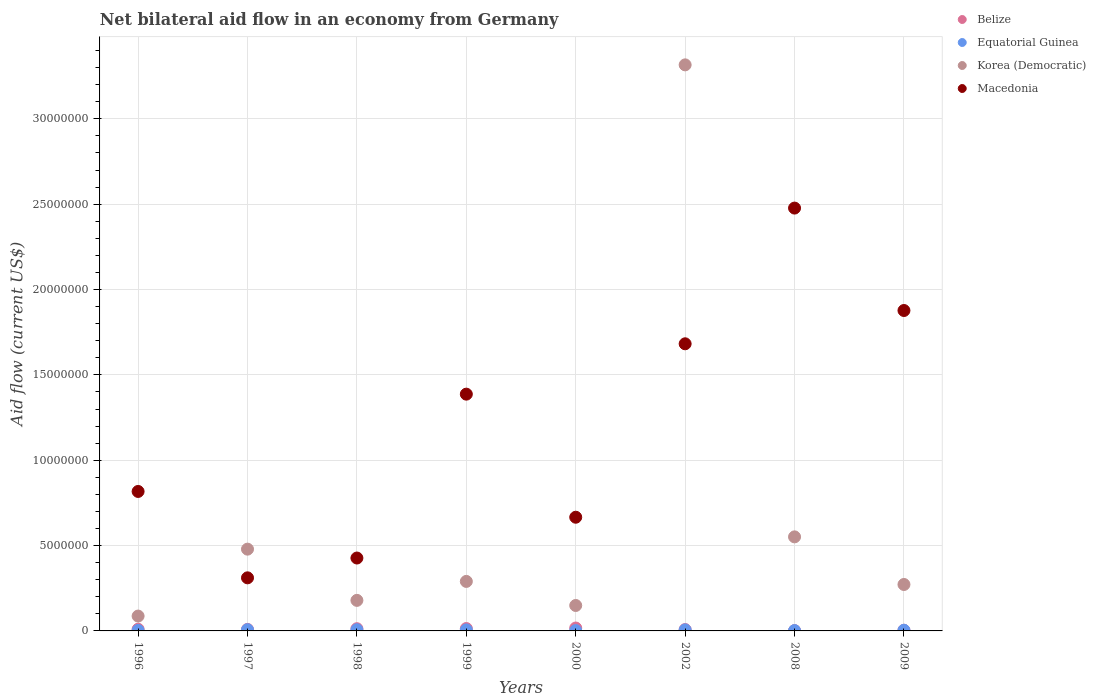Is the number of dotlines equal to the number of legend labels?
Your response must be concise. Yes. What is the net bilateral aid flow in Korea (Democratic) in 2002?
Offer a very short reply. 3.32e+07. Across all years, what is the maximum net bilateral aid flow in Belize?
Provide a short and direct response. 1.70e+05. Across all years, what is the minimum net bilateral aid flow in Korea (Democratic)?
Give a very brief answer. 8.70e+05. What is the total net bilateral aid flow in Macedonia in the graph?
Provide a short and direct response. 9.64e+07. What is the difference between the net bilateral aid flow in Belize in 1997 and the net bilateral aid flow in Equatorial Guinea in 2009?
Provide a short and direct response. 5.00e+04. What is the average net bilateral aid flow in Belize per year?
Provide a succinct answer. 9.62e+04. In how many years, is the net bilateral aid flow in Korea (Democratic) greater than 23000000 US$?
Your answer should be compact. 1. What is the ratio of the net bilateral aid flow in Macedonia in 1997 to that in 2002?
Your answer should be very brief. 0.18. What is the difference between the highest and the lowest net bilateral aid flow in Equatorial Guinea?
Make the answer very short. 5.00e+04. In how many years, is the net bilateral aid flow in Macedonia greater than the average net bilateral aid flow in Macedonia taken over all years?
Provide a short and direct response. 4. Is it the case that in every year, the sum of the net bilateral aid flow in Belize and net bilateral aid flow in Korea (Democratic)  is greater than the sum of net bilateral aid flow in Equatorial Guinea and net bilateral aid flow in Macedonia?
Your answer should be compact. Yes. Is it the case that in every year, the sum of the net bilateral aid flow in Equatorial Guinea and net bilateral aid flow in Korea (Democratic)  is greater than the net bilateral aid flow in Macedonia?
Provide a short and direct response. No. Does the net bilateral aid flow in Belize monotonically increase over the years?
Give a very brief answer. No. Is the net bilateral aid flow in Equatorial Guinea strictly greater than the net bilateral aid flow in Belize over the years?
Provide a succinct answer. No. Are the values on the major ticks of Y-axis written in scientific E-notation?
Give a very brief answer. No. Does the graph contain any zero values?
Give a very brief answer. No. Where does the legend appear in the graph?
Keep it short and to the point. Top right. What is the title of the graph?
Ensure brevity in your answer.  Net bilateral aid flow in an economy from Germany. What is the label or title of the X-axis?
Keep it short and to the point. Years. What is the Aid flow (current US$) in Belize in 1996?
Ensure brevity in your answer.  1.00e+05. What is the Aid flow (current US$) in Korea (Democratic) in 1996?
Keep it short and to the point. 8.70e+05. What is the Aid flow (current US$) in Macedonia in 1996?
Ensure brevity in your answer.  8.17e+06. What is the Aid flow (current US$) in Equatorial Guinea in 1997?
Your answer should be compact. 7.00e+04. What is the Aid flow (current US$) of Korea (Democratic) in 1997?
Ensure brevity in your answer.  4.79e+06. What is the Aid flow (current US$) of Macedonia in 1997?
Give a very brief answer. 3.11e+06. What is the Aid flow (current US$) of Belize in 1998?
Offer a very short reply. 1.30e+05. What is the Aid flow (current US$) of Equatorial Guinea in 1998?
Your response must be concise. 7.00e+04. What is the Aid flow (current US$) of Korea (Democratic) in 1998?
Provide a short and direct response. 1.79e+06. What is the Aid flow (current US$) of Macedonia in 1998?
Your answer should be compact. 4.27e+06. What is the Aid flow (current US$) of Equatorial Guinea in 1999?
Keep it short and to the point. 6.00e+04. What is the Aid flow (current US$) in Korea (Democratic) in 1999?
Your response must be concise. 2.90e+06. What is the Aid flow (current US$) of Macedonia in 1999?
Provide a succinct answer. 1.39e+07. What is the Aid flow (current US$) in Belize in 2000?
Your answer should be very brief. 1.70e+05. What is the Aid flow (current US$) of Equatorial Guinea in 2000?
Keep it short and to the point. 2.00e+04. What is the Aid flow (current US$) of Korea (Democratic) in 2000?
Provide a succinct answer. 1.49e+06. What is the Aid flow (current US$) of Macedonia in 2000?
Provide a succinct answer. 6.66e+06. What is the Aid flow (current US$) of Belize in 2002?
Keep it short and to the point. 8.00e+04. What is the Aid flow (current US$) in Korea (Democratic) in 2002?
Provide a succinct answer. 3.32e+07. What is the Aid flow (current US$) of Macedonia in 2002?
Give a very brief answer. 1.68e+07. What is the Aid flow (current US$) of Belize in 2008?
Your answer should be compact. 2.00e+04. What is the Aid flow (current US$) in Equatorial Guinea in 2008?
Keep it short and to the point. 2.00e+04. What is the Aid flow (current US$) of Korea (Democratic) in 2008?
Your answer should be compact. 5.51e+06. What is the Aid flow (current US$) of Macedonia in 2008?
Your answer should be compact. 2.48e+07. What is the Aid flow (current US$) in Belize in 2009?
Keep it short and to the point. 4.00e+04. What is the Aid flow (current US$) in Korea (Democratic) in 2009?
Provide a succinct answer. 2.72e+06. What is the Aid flow (current US$) of Macedonia in 2009?
Keep it short and to the point. 1.88e+07. Across all years, what is the maximum Aid flow (current US$) in Equatorial Guinea?
Provide a short and direct response. 7.00e+04. Across all years, what is the maximum Aid flow (current US$) of Korea (Democratic)?
Your answer should be very brief. 3.32e+07. Across all years, what is the maximum Aid flow (current US$) in Macedonia?
Provide a succinct answer. 2.48e+07. Across all years, what is the minimum Aid flow (current US$) in Belize?
Your answer should be very brief. 2.00e+04. Across all years, what is the minimum Aid flow (current US$) in Korea (Democratic)?
Offer a terse response. 8.70e+05. Across all years, what is the minimum Aid flow (current US$) in Macedonia?
Your answer should be compact. 3.11e+06. What is the total Aid flow (current US$) of Belize in the graph?
Make the answer very short. 7.70e+05. What is the total Aid flow (current US$) in Equatorial Guinea in the graph?
Keep it short and to the point. 3.70e+05. What is the total Aid flow (current US$) of Korea (Democratic) in the graph?
Your response must be concise. 5.32e+07. What is the total Aid flow (current US$) of Macedonia in the graph?
Offer a terse response. 9.64e+07. What is the difference between the Aid flow (current US$) in Korea (Democratic) in 1996 and that in 1997?
Provide a short and direct response. -3.92e+06. What is the difference between the Aid flow (current US$) in Macedonia in 1996 and that in 1997?
Offer a terse response. 5.06e+06. What is the difference between the Aid flow (current US$) of Equatorial Guinea in 1996 and that in 1998?
Keep it short and to the point. -4.00e+04. What is the difference between the Aid flow (current US$) in Korea (Democratic) in 1996 and that in 1998?
Give a very brief answer. -9.20e+05. What is the difference between the Aid flow (current US$) in Macedonia in 1996 and that in 1998?
Your answer should be compact. 3.90e+06. What is the difference between the Aid flow (current US$) in Korea (Democratic) in 1996 and that in 1999?
Give a very brief answer. -2.03e+06. What is the difference between the Aid flow (current US$) in Macedonia in 1996 and that in 1999?
Your answer should be compact. -5.70e+06. What is the difference between the Aid flow (current US$) of Belize in 1996 and that in 2000?
Keep it short and to the point. -7.00e+04. What is the difference between the Aid flow (current US$) in Equatorial Guinea in 1996 and that in 2000?
Offer a very short reply. 10000. What is the difference between the Aid flow (current US$) of Korea (Democratic) in 1996 and that in 2000?
Offer a very short reply. -6.20e+05. What is the difference between the Aid flow (current US$) of Macedonia in 1996 and that in 2000?
Provide a short and direct response. 1.51e+06. What is the difference between the Aid flow (current US$) of Korea (Democratic) in 1996 and that in 2002?
Provide a succinct answer. -3.23e+07. What is the difference between the Aid flow (current US$) in Macedonia in 1996 and that in 2002?
Your answer should be very brief. -8.65e+06. What is the difference between the Aid flow (current US$) in Belize in 1996 and that in 2008?
Your response must be concise. 8.00e+04. What is the difference between the Aid flow (current US$) of Korea (Democratic) in 1996 and that in 2008?
Offer a terse response. -4.64e+06. What is the difference between the Aid flow (current US$) in Macedonia in 1996 and that in 2008?
Provide a short and direct response. -1.66e+07. What is the difference between the Aid flow (current US$) in Belize in 1996 and that in 2009?
Your answer should be compact. 6.00e+04. What is the difference between the Aid flow (current US$) in Korea (Democratic) in 1996 and that in 2009?
Provide a succinct answer. -1.85e+06. What is the difference between the Aid flow (current US$) in Macedonia in 1996 and that in 2009?
Provide a succinct answer. -1.06e+07. What is the difference between the Aid flow (current US$) of Belize in 1997 and that in 1998?
Offer a terse response. -4.00e+04. What is the difference between the Aid flow (current US$) of Macedonia in 1997 and that in 1998?
Provide a succinct answer. -1.16e+06. What is the difference between the Aid flow (current US$) in Equatorial Guinea in 1997 and that in 1999?
Provide a succinct answer. 10000. What is the difference between the Aid flow (current US$) in Korea (Democratic) in 1997 and that in 1999?
Keep it short and to the point. 1.89e+06. What is the difference between the Aid flow (current US$) of Macedonia in 1997 and that in 1999?
Provide a short and direct response. -1.08e+07. What is the difference between the Aid flow (current US$) of Equatorial Guinea in 1997 and that in 2000?
Offer a very short reply. 5.00e+04. What is the difference between the Aid flow (current US$) of Korea (Democratic) in 1997 and that in 2000?
Offer a terse response. 3.30e+06. What is the difference between the Aid flow (current US$) of Macedonia in 1997 and that in 2000?
Make the answer very short. -3.55e+06. What is the difference between the Aid flow (current US$) of Equatorial Guinea in 1997 and that in 2002?
Your answer should be compact. 10000. What is the difference between the Aid flow (current US$) in Korea (Democratic) in 1997 and that in 2002?
Offer a terse response. -2.84e+07. What is the difference between the Aid flow (current US$) in Macedonia in 1997 and that in 2002?
Offer a terse response. -1.37e+07. What is the difference between the Aid flow (current US$) of Korea (Democratic) in 1997 and that in 2008?
Provide a succinct answer. -7.20e+05. What is the difference between the Aid flow (current US$) in Macedonia in 1997 and that in 2008?
Offer a very short reply. -2.17e+07. What is the difference between the Aid flow (current US$) of Equatorial Guinea in 1997 and that in 2009?
Offer a very short reply. 3.00e+04. What is the difference between the Aid flow (current US$) in Korea (Democratic) in 1997 and that in 2009?
Provide a succinct answer. 2.07e+06. What is the difference between the Aid flow (current US$) of Macedonia in 1997 and that in 2009?
Your answer should be compact. -1.57e+07. What is the difference between the Aid flow (current US$) of Equatorial Guinea in 1998 and that in 1999?
Ensure brevity in your answer.  10000. What is the difference between the Aid flow (current US$) of Korea (Democratic) in 1998 and that in 1999?
Your response must be concise. -1.11e+06. What is the difference between the Aid flow (current US$) in Macedonia in 1998 and that in 1999?
Your answer should be compact. -9.60e+06. What is the difference between the Aid flow (current US$) in Equatorial Guinea in 1998 and that in 2000?
Make the answer very short. 5.00e+04. What is the difference between the Aid flow (current US$) in Macedonia in 1998 and that in 2000?
Keep it short and to the point. -2.39e+06. What is the difference between the Aid flow (current US$) in Belize in 1998 and that in 2002?
Ensure brevity in your answer.  5.00e+04. What is the difference between the Aid flow (current US$) of Equatorial Guinea in 1998 and that in 2002?
Your response must be concise. 10000. What is the difference between the Aid flow (current US$) of Korea (Democratic) in 1998 and that in 2002?
Keep it short and to the point. -3.14e+07. What is the difference between the Aid flow (current US$) of Macedonia in 1998 and that in 2002?
Give a very brief answer. -1.26e+07. What is the difference between the Aid flow (current US$) in Belize in 1998 and that in 2008?
Offer a very short reply. 1.10e+05. What is the difference between the Aid flow (current US$) in Equatorial Guinea in 1998 and that in 2008?
Your response must be concise. 5.00e+04. What is the difference between the Aid flow (current US$) of Korea (Democratic) in 1998 and that in 2008?
Your answer should be very brief. -3.72e+06. What is the difference between the Aid flow (current US$) in Macedonia in 1998 and that in 2008?
Keep it short and to the point. -2.05e+07. What is the difference between the Aid flow (current US$) of Belize in 1998 and that in 2009?
Offer a very short reply. 9.00e+04. What is the difference between the Aid flow (current US$) of Equatorial Guinea in 1998 and that in 2009?
Provide a succinct answer. 3.00e+04. What is the difference between the Aid flow (current US$) of Korea (Democratic) in 1998 and that in 2009?
Provide a succinct answer. -9.30e+05. What is the difference between the Aid flow (current US$) of Macedonia in 1998 and that in 2009?
Offer a very short reply. -1.45e+07. What is the difference between the Aid flow (current US$) of Korea (Democratic) in 1999 and that in 2000?
Your answer should be compact. 1.41e+06. What is the difference between the Aid flow (current US$) in Macedonia in 1999 and that in 2000?
Offer a terse response. 7.21e+06. What is the difference between the Aid flow (current US$) of Equatorial Guinea in 1999 and that in 2002?
Offer a terse response. 0. What is the difference between the Aid flow (current US$) in Korea (Democratic) in 1999 and that in 2002?
Offer a very short reply. -3.03e+07. What is the difference between the Aid flow (current US$) of Macedonia in 1999 and that in 2002?
Provide a short and direct response. -2.95e+06. What is the difference between the Aid flow (current US$) in Equatorial Guinea in 1999 and that in 2008?
Your answer should be compact. 4.00e+04. What is the difference between the Aid flow (current US$) in Korea (Democratic) in 1999 and that in 2008?
Give a very brief answer. -2.61e+06. What is the difference between the Aid flow (current US$) in Macedonia in 1999 and that in 2008?
Offer a terse response. -1.09e+07. What is the difference between the Aid flow (current US$) in Belize in 1999 and that in 2009?
Ensure brevity in your answer.  1.00e+05. What is the difference between the Aid flow (current US$) of Equatorial Guinea in 1999 and that in 2009?
Give a very brief answer. 2.00e+04. What is the difference between the Aid flow (current US$) in Korea (Democratic) in 1999 and that in 2009?
Your answer should be compact. 1.80e+05. What is the difference between the Aid flow (current US$) in Macedonia in 1999 and that in 2009?
Give a very brief answer. -4.90e+06. What is the difference between the Aid flow (current US$) in Belize in 2000 and that in 2002?
Give a very brief answer. 9.00e+04. What is the difference between the Aid flow (current US$) in Korea (Democratic) in 2000 and that in 2002?
Keep it short and to the point. -3.17e+07. What is the difference between the Aid flow (current US$) in Macedonia in 2000 and that in 2002?
Provide a succinct answer. -1.02e+07. What is the difference between the Aid flow (current US$) in Belize in 2000 and that in 2008?
Ensure brevity in your answer.  1.50e+05. What is the difference between the Aid flow (current US$) in Equatorial Guinea in 2000 and that in 2008?
Offer a very short reply. 0. What is the difference between the Aid flow (current US$) in Korea (Democratic) in 2000 and that in 2008?
Your response must be concise. -4.02e+06. What is the difference between the Aid flow (current US$) in Macedonia in 2000 and that in 2008?
Your response must be concise. -1.81e+07. What is the difference between the Aid flow (current US$) of Korea (Democratic) in 2000 and that in 2009?
Your answer should be very brief. -1.23e+06. What is the difference between the Aid flow (current US$) in Macedonia in 2000 and that in 2009?
Your response must be concise. -1.21e+07. What is the difference between the Aid flow (current US$) in Belize in 2002 and that in 2008?
Provide a succinct answer. 6.00e+04. What is the difference between the Aid flow (current US$) of Korea (Democratic) in 2002 and that in 2008?
Your answer should be compact. 2.76e+07. What is the difference between the Aid flow (current US$) in Macedonia in 2002 and that in 2008?
Ensure brevity in your answer.  -7.95e+06. What is the difference between the Aid flow (current US$) in Korea (Democratic) in 2002 and that in 2009?
Offer a very short reply. 3.04e+07. What is the difference between the Aid flow (current US$) in Macedonia in 2002 and that in 2009?
Keep it short and to the point. -1.95e+06. What is the difference between the Aid flow (current US$) in Belize in 2008 and that in 2009?
Your answer should be compact. -2.00e+04. What is the difference between the Aid flow (current US$) in Equatorial Guinea in 2008 and that in 2009?
Your response must be concise. -2.00e+04. What is the difference between the Aid flow (current US$) of Korea (Democratic) in 2008 and that in 2009?
Your answer should be compact. 2.79e+06. What is the difference between the Aid flow (current US$) in Macedonia in 2008 and that in 2009?
Provide a short and direct response. 6.00e+06. What is the difference between the Aid flow (current US$) of Belize in 1996 and the Aid flow (current US$) of Equatorial Guinea in 1997?
Give a very brief answer. 3.00e+04. What is the difference between the Aid flow (current US$) of Belize in 1996 and the Aid flow (current US$) of Korea (Democratic) in 1997?
Offer a terse response. -4.69e+06. What is the difference between the Aid flow (current US$) in Belize in 1996 and the Aid flow (current US$) in Macedonia in 1997?
Your answer should be very brief. -3.01e+06. What is the difference between the Aid flow (current US$) in Equatorial Guinea in 1996 and the Aid flow (current US$) in Korea (Democratic) in 1997?
Provide a short and direct response. -4.76e+06. What is the difference between the Aid flow (current US$) of Equatorial Guinea in 1996 and the Aid flow (current US$) of Macedonia in 1997?
Offer a very short reply. -3.08e+06. What is the difference between the Aid flow (current US$) in Korea (Democratic) in 1996 and the Aid flow (current US$) in Macedonia in 1997?
Offer a terse response. -2.24e+06. What is the difference between the Aid flow (current US$) in Belize in 1996 and the Aid flow (current US$) in Korea (Democratic) in 1998?
Offer a very short reply. -1.69e+06. What is the difference between the Aid flow (current US$) of Belize in 1996 and the Aid flow (current US$) of Macedonia in 1998?
Provide a short and direct response. -4.17e+06. What is the difference between the Aid flow (current US$) of Equatorial Guinea in 1996 and the Aid flow (current US$) of Korea (Democratic) in 1998?
Your answer should be compact. -1.76e+06. What is the difference between the Aid flow (current US$) in Equatorial Guinea in 1996 and the Aid flow (current US$) in Macedonia in 1998?
Provide a short and direct response. -4.24e+06. What is the difference between the Aid flow (current US$) of Korea (Democratic) in 1996 and the Aid flow (current US$) of Macedonia in 1998?
Provide a short and direct response. -3.40e+06. What is the difference between the Aid flow (current US$) in Belize in 1996 and the Aid flow (current US$) in Korea (Democratic) in 1999?
Provide a short and direct response. -2.80e+06. What is the difference between the Aid flow (current US$) of Belize in 1996 and the Aid flow (current US$) of Macedonia in 1999?
Your answer should be compact. -1.38e+07. What is the difference between the Aid flow (current US$) in Equatorial Guinea in 1996 and the Aid flow (current US$) in Korea (Democratic) in 1999?
Make the answer very short. -2.87e+06. What is the difference between the Aid flow (current US$) of Equatorial Guinea in 1996 and the Aid flow (current US$) of Macedonia in 1999?
Your response must be concise. -1.38e+07. What is the difference between the Aid flow (current US$) of Korea (Democratic) in 1996 and the Aid flow (current US$) of Macedonia in 1999?
Your answer should be compact. -1.30e+07. What is the difference between the Aid flow (current US$) of Belize in 1996 and the Aid flow (current US$) of Korea (Democratic) in 2000?
Provide a succinct answer. -1.39e+06. What is the difference between the Aid flow (current US$) in Belize in 1996 and the Aid flow (current US$) in Macedonia in 2000?
Provide a succinct answer. -6.56e+06. What is the difference between the Aid flow (current US$) of Equatorial Guinea in 1996 and the Aid flow (current US$) of Korea (Democratic) in 2000?
Your response must be concise. -1.46e+06. What is the difference between the Aid flow (current US$) of Equatorial Guinea in 1996 and the Aid flow (current US$) of Macedonia in 2000?
Your answer should be very brief. -6.63e+06. What is the difference between the Aid flow (current US$) in Korea (Democratic) in 1996 and the Aid flow (current US$) in Macedonia in 2000?
Your answer should be compact. -5.79e+06. What is the difference between the Aid flow (current US$) of Belize in 1996 and the Aid flow (current US$) of Korea (Democratic) in 2002?
Keep it short and to the point. -3.31e+07. What is the difference between the Aid flow (current US$) of Belize in 1996 and the Aid flow (current US$) of Macedonia in 2002?
Give a very brief answer. -1.67e+07. What is the difference between the Aid flow (current US$) in Equatorial Guinea in 1996 and the Aid flow (current US$) in Korea (Democratic) in 2002?
Give a very brief answer. -3.31e+07. What is the difference between the Aid flow (current US$) of Equatorial Guinea in 1996 and the Aid flow (current US$) of Macedonia in 2002?
Ensure brevity in your answer.  -1.68e+07. What is the difference between the Aid flow (current US$) of Korea (Democratic) in 1996 and the Aid flow (current US$) of Macedonia in 2002?
Give a very brief answer. -1.60e+07. What is the difference between the Aid flow (current US$) in Belize in 1996 and the Aid flow (current US$) in Equatorial Guinea in 2008?
Your answer should be very brief. 8.00e+04. What is the difference between the Aid flow (current US$) of Belize in 1996 and the Aid flow (current US$) of Korea (Democratic) in 2008?
Give a very brief answer. -5.41e+06. What is the difference between the Aid flow (current US$) in Belize in 1996 and the Aid flow (current US$) in Macedonia in 2008?
Give a very brief answer. -2.47e+07. What is the difference between the Aid flow (current US$) in Equatorial Guinea in 1996 and the Aid flow (current US$) in Korea (Democratic) in 2008?
Give a very brief answer. -5.48e+06. What is the difference between the Aid flow (current US$) of Equatorial Guinea in 1996 and the Aid flow (current US$) of Macedonia in 2008?
Your response must be concise. -2.47e+07. What is the difference between the Aid flow (current US$) of Korea (Democratic) in 1996 and the Aid flow (current US$) of Macedonia in 2008?
Make the answer very short. -2.39e+07. What is the difference between the Aid flow (current US$) in Belize in 1996 and the Aid flow (current US$) in Equatorial Guinea in 2009?
Your answer should be very brief. 6.00e+04. What is the difference between the Aid flow (current US$) of Belize in 1996 and the Aid flow (current US$) of Korea (Democratic) in 2009?
Your answer should be compact. -2.62e+06. What is the difference between the Aid flow (current US$) of Belize in 1996 and the Aid flow (current US$) of Macedonia in 2009?
Provide a short and direct response. -1.87e+07. What is the difference between the Aid flow (current US$) in Equatorial Guinea in 1996 and the Aid flow (current US$) in Korea (Democratic) in 2009?
Give a very brief answer. -2.69e+06. What is the difference between the Aid flow (current US$) of Equatorial Guinea in 1996 and the Aid flow (current US$) of Macedonia in 2009?
Keep it short and to the point. -1.87e+07. What is the difference between the Aid flow (current US$) of Korea (Democratic) in 1996 and the Aid flow (current US$) of Macedonia in 2009?
Provide a succinct answer. -1.79e+07. What is the difference between the Aid flow (current US$) of Belize in 1997 and the Aid flow (current US$) of Korea (Democratic) in 1998?
Your answer should be very brief. -1.70e+06. What is the difference between the Aid flow (current US$) of Belize in 1997 and the Aid flow (current US$) of Macedonia in 1998?
Give a very brief answer. -4.18e+06. What is the difference between the Aid flow (current US$) in Equatorial Guinea in 1997 and the Aid flow (current US$) in Korea (Democratic) in 1998?
Ensure brevity in your answer.  -1.72e+06. What is the difference between the Aid flow (current US$) of Equatorial Guinea in 1997 and the Aid flow (current US$) of Macedonia in 1998?
Provide a short and direct response. -4.20e+06. What is the difference between the Aid flow (current US$) of Korea (Democratic) in 1997 and the Aid flow (current US$) of Macedonia in 1998?
Provide a succinct answer. 5.20e+05. What is the difference between the Aid flow (current US$) of Belize in 1997 and the Aid flow (current US$) of Equatorial Guinea in 1999?
Give a very brief answer. 3.00e+04. What is the difference between the Aid flow (current US$) of Belize in 1997 and the Aid flow (current US$) of Korea (Democratic) in 1999?
Provide a succinct answer. -2.81e+06. What is the difference between the Aid flow (current US$) in Belize in 1997 and the Aid flow (current US$) in Macedonia in 1999?
Make the answer very short. -1.38e+07. What is the difference between the Aid flow (current US$) in Equatorial Guinea in 1997 and the Aid flow (current US$) in Korea (Democratic) in 1999?
Provide a succinct answer. -2.83e+06. What is the difference between the Aid flow (current US$) in Equatorial Guinea in 1997 and the Aid flow (current US$) in Macedonia in 1999?
Your response must be concise. -1.38e+07. What is the difference between the Aid flow (current US$) of Korea (Democratic) in 1997 and the Aid flow (current US$) of Macedonia in 1999?
Offer a very short reply. -9.08e+06. What is the difference between the Aid flow (current US$) in Belize in 1997 and the Aid flow (current US$) in Korea (Democratic) in 2000?
Offer a very short reply. -1.40e+06. What is the difference between the Aid flow (current US$) of Belize in 1997 and the Aid flow (current US$) of Macedonia in 2000?
Offer a very short reply. -6.57e+06. What is the difference between the Aid flow (current US$) in Equatorial Guinea in 1997 and the Aid flow (current US$) in Korea (Democratic) in 2000?
Make the answer very short. -1.42e+06. What is the difference between the Aid flow (current US$) in Equatorial Guinea in 1997 and the Aid flow (current US$) in Macedonia in 2000?
Provide a succinct answer. -6.59e+06. What is the difference between the Aid flow (current US$) of Korea (Democratic) in 1997 and the Aid flow (current US$) of Macedonia in 2000?
Ensure brevity in your answer.  -1.87e+06. What is the difference between the Aid flow (current US$) in Belize in 1997 and the Aid flow (current US$) in Korea (Democratic) in 2002?
Offer a very short reply. -3.31e+07. What is the difference between the Aid flow (current US$) of Belize in 1997 and the Aid flow (current US$) of Macedonia in 2002?
Ensure brevity in your answer.  -1.67e+07. What is the difference between the Aid flow (current US$) of Equatorial Guinea in 1997 and the Aid flow (current US$) of Korea (Democratic) in 2002?
Provide a succinct answer. -3.31e+07. What is the difference between the Aid flow (current US$) of Equatorial Guinea in 1997 and the Aid flow (current US$) of Macedonia in 2002?
Provide a short and direct response. -1.68e+07. What is the difference between the Aid flow (current US$) in Korea (Democratic) in 1997 and the Aid flow (current US$) in Macedonia in 2002?
Provide a succinct answer. -1.20e+07. What is the difference between the Aid flow (current US$) in Belize in 1997 and the Aid flow (current US$) in Korea (Democratic) in 2008?
Your answer should be very brief. -5.42e+06. What is the difference between the Aid flow (current US$) of Belize in 1997 and the Aid flow (current US$) of Macedonia in 2008?
Provide a short and direct response. -2.47e+07. What is the difference between the Aid flow (current US$) of Equatorial Guinea in 1997 and the Aid flow (current US$) of Korea (Democratic) in 2008?
Ensure brevity in your answer.  -5.44e+06. What is the difference between the Aid flow (current US$) of Equatorial Guinea in 1997 and the Aid flow (current US$) of Macedonia in 2008?
Make the answer very short. -2.47e+07. What is the difference between the Aid flow (current US$) in Korea (Democratic) in 1997 and the Aid flow (current US$) in Macedonia in 2008?
Your answer should be very brief. -2.00e+07. What is the difference between the Aid flow (current US$) in Belize in 1997 and the Aid flow (current US$) in Equatorial Guinea in 2009?
Your response must be concise. 5.00e+04. What is the difference between the Aid flow (current US$) in Belize in 1997 and the Aid flow (current US$) in Korea (Democratic) in 2009?
Ensure brevity in your answer.  -2.63e+06. What is the difference between the Aid flow (current US$) of Belize in 1997 and the Aid flow (current US$) of Macedonia in 2009?
Ensure brevity in your answer.  -1.87e+07. What is the difference between the Aid flow (current US$) in Equatorial Guinea in 1997 and the Aid flow (current US$) in Korea (Democratic) in 2009?
Your answer should be very brief. -2.65e+06. What is the difference between the Aid flow (current US$) of Equatorial Guinea in 1997 and the Aid flow (current US$) of Macedonia in 2009?
Your response must be concise. -1.87e+07. What is the difference between the Aid flow (current US$) in Korea (Democratic) in 1997 and the Aid flow (current US$) in Macedonia in 2009?
Provide a short and direct response. -1.40e+07. What is the difference between the Aid flow (current US$) in Belize in 1998 and the Aid flow (current US$) in Equatorial Guinea in 1999?
Keep it short and to the point. 7.00e+04. What is the difference between the Aid flow (current US$) of Belize in 1998 and the Aid flow (current US$) of Korea (Democratic) in 1999?
Your response must be concise. -2.77e+06. What is the difference between the Aid flow (current US$) in Belize in 1998 and the Aid flow (current US$) in Macedonia in 1999?
Your answer should be very brief. -1.37e+07. What is the difference between the Aid flow (current US$) of Equatorial Guinea in 1998 and the Aid flow (current US$) of Korea (Democratic) in 1999?
Offer a terse response. -2.83e+06. What is the difference between the Aid flow (current US$) in Equatorial Guinea in 1998 and the Aid flow (current US$) in Macedonia in 1999?
Your response must be concise. -1.38e+07. What is the difference between the Aid flow (current US$) in Korea (Democratic) in 1998 and the Aid flow (current US$) in Macedonia in 1999?
Offer a very short reply. -1.21e+07. What is the difference between the Aid flow (current US$) of Belize in 1998 and the Aid flow (current US$) of Korea (Democratic) in 2000?
Give a very brief answer. -1.36e+06. What is the difference between the Aid flow (current US$) of Belize in 1998 and the Aid flow (current US$) of Macedonia in 2000?
Your response must be concise. -6.53e+06. What is the difference between the Aid flow (current US$) in Equatorial Guinea in 1998 and the Aid flow (current US$) in Korea (Democratic) in 2000?
Make the answer very short. -1.42e+06. What is the difference between the Aid flow (current US$) in Equatorial Guinea in 1998 and the Aid flow (current US$) in Macedonia in 2000?
Provide a succinct answer. -6.59e+06. What is the difference between the Aid flow (current US$) of Korea (Democratic) in 1998 and the Aid flow (current US$) of Macedonia in 2000?
Your response must be concise. -4.87e+06. What is the difference between the Aid flow (current US$) of Belize in 1998 and the Aid flow (current US$) of Equatorial Guinea in 2002?
Your response must be concise. 7.00e+04. What is the difference between the Aid flow (current US$) in Belize in 1998 and the Aid flow (current US$) in Korea (Democratic) in 2002?
Your answer should be compact. -3.30e+07. What is the difference between the Aid flow (current US$) of Belize in 1998 and the Aid flow (current US$) of Macedonia in 2002?
Provide a succinct answer. -1.67e+07. What is the difference between the Aid flow (current US$) of Equatorial Guinea in 1998 and the Aid flow (current US$) of Korea (Democratic) in 2002?
Ensure brevity in your answer.  -3.31e+07. What is the difference between the Aid flow (current US$) in Equatorial Guinea in 1998 and the Aid flow (current US$) in Macedonia in 2002?
Offer a very short reply. -1.68e+07. What is the difference between the Aid flow (current US$) of Korea (Democratic) in 1998 and the Aid flow (current US$) of Macedonia in 2002?
Offer a terse response. -1.50e+07. What is the difference between the Aid flow (current US$) in Belize in 1998 and the Aid flow (current US$) in Equatorial Guinea in 2008?
Offer a very short reply. 1.10e+05. What is the difference between the Aid flow (current US$) of Belize in 1998 and the Aid flow (current US$) of Korea (Democratic) in 2008?
Give a very brief answer. -5.38e+06. What is the difference between the Aid flow (current US$) of Belize in 1998 and the Aid flow (current US$) of Macedonia in 2008?
Provide a short and direct response. -2.46e+07. What is the difference between the Aid flow (current US$) of Equatorial Guinea in 1998 and the Aid flow (current US$) of Korea (Democratic) in 2008?
Give a very brief answer. -5.44e+06. What is the difference between the Aid flow (current US$) in Equatorial Guinea in 1998 and the Aid flow (current US$) in Macedonia in 2008?
Keep it short and to the point. -2.47e+07. What is the difference between the Aid flow (current US$) of Korea (Democratic) in 1998 and the Aid flow (current US$) of Macedonia in 2008?
Offer a terse response. -2.30e+07. What is the difference between the Aid flow (current US$) in Belize in 1998 and the Aid flow (current US$) in Korea (Democratic) in 2009?
Provide a succinct answer. -2.59e+06. What is the difference between the Aid flow (current US$) of Belize in 1998 and the Aid flow (current US$) of Macedonia in 2009?
Keep it short and to the point. -1.86e+07. What is the difference between the Aid flow (current US$) of Equatorial Guinea in 1998 and the Aid flow (current US$) of Korea (Democratic) in 2009?
Give a very brief answer. -2.65e+06. What is the difference between the Aid flow (current US$) of Equatorial Guinea in 1998 and the Aid flow (current US$) of Macedonia in 2009?
Provide a succinct answer. -1.87e+07. What is the difference between the Aid flow (current US$) in Korea (Democratic) in 1998 and the Aid flow (current US$) in Macedonia in 2009?
Make the answer very short. -1.70e+07. What is the difference between the Aid flow (current US$) of Belize in 1999 and the Aid flow (current US$) of Equatorial Guinea in 2000?
Offer a very short reply. 1.20e+05. What is the difference between the Aid flow (current US$) in Belize in 1999 and the Aid flow (current US$) in Korea (Democratic) in 2000?
Offer a terse response. -1.35e+06. What is the difference between the Aid flow (current US$) in Belize in 1999 and the Aid flow (current US$) in Macedonia in 2000?
Your answer should be compact. -6.52e+06. What is the difference between the Aid flow (current US$) of Equatorial Guinea in 1999 and the Aid flow (current US$) of Korea (Democratic) in 2000?
Provide a short and direct response. -1.43e+06. What is the difference between the Aid flow (current US$) in Equatorial Guinea in 1999 and the Aid flow (current US$) in Macedonia in 2000?
Your answer should be compact. -6.60e+06. What is the difference between the Aid flow (current US$) in Korea (Democratic) in 1999 and the Aid flow (current US$) in Macedonia in 2000?
Your answer should be compact. -3.76e+06. What is the difference between the Aid flow (current US$) in Belize in 1999 and the Aid flow (current US$) in Equatorial Guinea in 2002?
Ensure brevity in your answer.  8.00e+04. What is the difference between the Aid flow (current US$) of Belize in 1999 and the Aid flow (current US$) of Korea (Democratic) in 2002?
Keep it short and to the point. -3.30e+07. What is the difference between the Aid flow (current US$) in Belize in 1999 and the Aid flow (current US$) in Macedonia in 2002?
Provide a short and direct response. -1.67e+07. What is the difference between the Aid flow (current US$) of Equatorial Guinea in 1999 and the Aid flow (current US$) of Korea (Democratic) in 2002?
Make the answer very short. -3.31e+07. What is the difference between the Aid flow (current US$) of Equatorial Guinea in 1999 and the Aid flow (current US$) of Macedonia in 2002?
Ensure brevity in your answer.  -1.68e+07. What is the difference between the Aid flow (current US$) of Korea (Democratic) in 1999 and the Aid flow (current US$) of Macedonia in 2002?
Give a very brief answer. -1.39e+07. What is the difference between the Aid flow (current US$) in Belize in 1999 and the Aid flow (current US$) in Equatorial Guinea in 2008?
Make the answer very short. 1.20e+05. What is the difference between the Aid flow (current US$) in Belize in 1999 and the Aid flow (current US$) in Korea (Democratic) in 2008?
Ensure brevity in your answer.  -5.37e+06. What is the difference between the Aid flow (current US$) in Belize in 1999 and the Aid flow (current US$) in Macedonia in 2008?
Your answer should be very brief. -2.46e+07. What is the difference between the Aid flow (current US$) in Equatorial Guinea in 1999 and the Aid flow (current US$) in Korea (Democratic) in 2008?
Make the answer very short. -5.45e+06. What is the difference between the Aid flow (current US$) in Equatorial Guinea in 1999 and the Aid flow (current US$) in Macedonia in 2008?
Provide a succinct answer. -2.47e+07. What is the difference between the Aid flow (current US$) of Korea (Democratic) in 1999 and the Aid flow (current US$) of Macedonia in 2008?
Make the answer very short. -2.19e+07. What is the difference between the Aid flow (current US$) in Belize in 1999 and the Aid flow (current US$) in Korea (Democratic) in 2009?
Provide a succinct answer. -2.58e+06. What is the difference between the Aid flow (current US$) of Belize in 1999 and the Aid flow (current US$) of Macedonia in 2009?
Keep it short and to the point. -1.86e+07. What is the difference between the Aid flow (current US$) of Equatorial Guinea in 1999 and the Aid flow (current US$) of Korea (Democratic) in 2009?
Give a very brief answer. -2.66e+06. What is the difference between the Aid flow (current US$) in Equatorial Guinea in 1999 and the Aid flow (current US$) in Macedonia in 2009?
Offer a very short reply. -1.87e+07. What is the difference between the Aid flow (current US$) of Korea (Democratic) in 1999 and the Aid flow (current US$) of Macedonia in 2009?
Offer a terse response. -1.59e+07. What is the difference between the Aid flow (current US$) in Belize in 2000 and the Aid flow (current US$) in Equatorial Guinea in 2002?
Offer a very short reply. 1.10e+05. What is the difference between the Aid flow (current US$) of Belize in 2000 and the Aid flow (current US$) of Korea (Democratic) in 2002?
Keep it short and to the point. -3.30e+07. What is the difference between the Aid flow (current US$) in Belize in 2000 and the Aid flow (current US$) in Macedonia in 2002?
Offer a terse response. -1.66e+07. What is the difference between the Aid flow (current US$) in Equatorial Guinea in 2000 and the Aid flow (current US$) in Korea (Democratic) in 2002?
Provide a succinct answer. -3.31e+07. What is the difference between the Aid flow (current US$) in Equatorial Guinea in 2000 and the Aid flow (current US$) in Macedonia in 2002?
Ensure brevity in your answer.  -1.68e+07. What is the difference between the Aid flow (current US$) of Korea (Democratic) in 2000 and the Aid flow (current US$) of Macedonia in 2002?
Offer a terse response. -1.53e+07. What is the difference between the Aid flow (current US$) of Belize in 2000 and the Aid flow (current US$) of Korea (Democratic) in 2008?
Offer a terse response. -5.34e+06. What is the difference between the Aid flow (current US$) of Belize in 2000 and the Aid flow (current US$) of Macedonia in 2008?
Keep it short and to the point. -2.46e+07. What is the difference between the Aid flow (current US$) of Equatorial Guinea in 2000 and the Aid flow (current US$) of Korea (Democratic) in 2008?
Offer a terse response. -5.49e+06. What is the difference between the Aid flow (current US$) in Equatorial Guinea in 2000 and the Aid flow (current US$) in Macedonia in 2008?
Offer a terse response. -2.48e+07. What is the difference between the Aid flow (current US$) in Korea (Democratic) in 2000 and the Aid flow (current US$) in Macedonia in 2008?
Ensure brevity in your answer.  -2.33e+07. What is the difference between the Aid flow (current US$) in Belize in 2000 and the Aid flow (current US$) in Equatorial Guinea in 2009?
Offer a terse response. 1.30e+05. What is the difference between the Aid flow (current US$) in Belize in 2000 and the Aid flow (current US$) in Korea (Democratic) in 2009?
Provide a succinct answer. -2.55e+06. What is the difference between the Aid flow (current US$) of Belize in 2000 and the Aid flow (current US$) of Macedonia in 2009?
Offer a terse response. -1.86e+07. What is the difference between the Aid flow (current US$) in Equatorial Guinea in 2000 and the Aid flow (current US$) in Korea (Democratic) in 2009?
Give a very brief answer. -2.70e+06. What is the difference between the Aid flow (current US$) of Equatorial Guinea in 2000 and the Aid flow (current US$) of Macedonia in 2009?
Keep it short and to the point. -1.88e+07. What is the difference between the Aid flow (current US$) in Korea (Democratic) in 2000 and the Aid flow (current US$) in Macedonia in 2009?
Make the answer very short. -1.73e+07. What is the difference between the Aid flow (current US$) of Belize in 2002 and the Aid flow (current US$) of Equatorial Guinea in 2008?
Ensure brevity in your answer.  6.00e+04. What is the difference between the Aid flow (current US$) in Belize in 2002 and the Aid flow (current US$) in Korea (Democratic) in 2008?
Make the answer very short. -5.43e+06. What is the difference between the Aid flow (current US$) of Belize in 2002 and the Aid flow (current US$) of Macedonia in 2008?
Make the answer very short. -2.47e+07. What is the difference between the Aid flow (current US$) of Equatorial Guinea in 2002 and the Aid flow (current US$) of Korea (Democratic) in 2008?
Ensure brevity in your answer.  -5.45e+06. What is the difference between the Aid flow (current US$) in Equatorial Guinea in 2002 and the Aid flow (current US$) in Macedonia in 2008?
Your answer should be compact. -2.47e+07. What is the difference between the Aid flow (current US$) in Korea (Democratic) in 2002 and the Aid flow (current US$) in Macedonia in 2008?
Provide a short and direct response. 8.39e+06. What is the difference between the Aid flow (current US$) of Belize in 2002 and the Aid flow (current US$) of Korea (Democratic) in 2009?
Offer a terse response. -2.64e+06. What is the difference between the Aid flow (current US$) of Belize in 2002 and the Aid flow (current US$) of Macedonia in 2009?
Keep it short and to the point. -1.87e+07. What is the difference between the Aid flow (current US$) of Equatorial Guinea in 2002 and the Aid flow (current US$) of Korea (Democratic) in 2009?
Offer a very short reply. -2.66e+06. What is the difference between the Aid flow (current US$) in Equatorial Guinea in 2002 and the Aid flow (current US$) in Macedonia in 2009?
Your answer should be compact. -1.87e+07. What is the difference between the Aid flow (current US$) in Korea (Democratic) in 2002 and the Aid flow (current US$) in Macedonia in 2009?
Provide a succinct answer. 1.44e+07. What is the difference between the Aid flow (current US$) of Belize in 2008 and the Aid flow (current US$) of Equatorial Guinea in 2009?
Provide a short and direct response. -2.00e+04. What is the difference between the Aid flow (current US$) of Belize in 2008 and the Aid flow (current US$) of Korea (Democratic) in 2009?
Your answer should be compact. -2.70e+06. What is the difference between the Aid flow (current US$) in Belize in 2008 and the Aid flow (current US$) in Macedonia in 2009?
Keep it short and to the point. -1.88e+07. What is the difference between the Aid flow (current US$) in Equatorial Guinea in 2008 and the Aid flow (current US$) in Korea (Democratic) in 2009?
Give a very brief answer. -2.70e+06. What is the difference between the Aid flow (current US$) of Equatorial Guinea in 2008 and the Aid flow (current US$) of Macedonia in 2009?
Your answer should be very brief. -1.88e+07. What is the difference between the Aid flow (current US$) in Korea (Democratic) in 2008 and the Aid flow (current US$) in Macedonia in 2009?
Your answer should be compact. -1.33e+07. What is the average Aid flow (current US$) of Belize per year?
Provide a succinct answer. 9.62e+04. What is the average Aid flow (current US$) in Equatorial Guinea per year?
Your answer should be compact. 4.62e+04. What is the average Aid flow (current US$) in Korea (Democratic) per year?
Make the answer very short. 6.65e+06. What is the average Aid flow (current US$) in Macedonia per year?
Your response must be concise. 1.21e+07. In the year 1996, what is the difference between the Aid flow (current US$) in Belize and Aid flow (current US$) in Korea (Democratic)?
Offer a terse response. -7.70e+05. In the year 1996, what is the difference between the Aid flow (current US$) of Belize and Aid flow (current US$) of Macedonia?
Keep it short and to the point. -8.07e+06. In the year 1996, what is the difference between the Aid flow (current US$) in Equatorial Guinea and Aid flow (current US$) in Korea (Democratic)?
Keep it short and to the point. -8.40e+05. In the year 1996, what is the difference between the Aid flow (current US$) in Equatorial Guinea and Aid flow (current US$) in Macedonia?
Offer a terse response. -8.14e+06. In the year 1996, what is the difference between the Aid flow (current US$) of Korea (Democratic) and Aid flow (current US$) of Macedonia?
Your response must be concise. -7.30e+06. In the year 1997, what is the difference between the Aid flow (current US$) of Belize and Aid flow (current US$) of Korea (Democratic)?
Your answer should be very brief. -4.70e+06. In the year 1997, what is the difference between the Aid flow (current US$) in Belize and Aid flow (current US$) in Macedonia?
Offer a very short reply. -3.02e+06. In the year 1997, what is the difference between the Aid flow (current US$) of Equatorial Guinea and Aid flow (current US$) of Korea (Democratic)?
Keep it short and to the point. -4.72e+06. In the year 1997, what is the difference between the Aid flow (current US$) in Equatorial Guinea and Aid flow (current US$) in Macedonia?
Your answer should be compact. -3.04e+06. In the year 1997, what is the difference between the Aid flow (current US$) in Korea (Democratic) and Aid flow (current US$) in Macedonia?
Offer a very short reply. 1.68e+06. In the year 1998, what is the difference between the Aid flow (current US$) in Belize and Aid flow (current US$) in Equatorial Guinea?
Your answer should be compact. 6.00e+04. In the year 1998, what is the difference between the Aid flow (current US$) of Belize and Aid flow (current US$) of Korea (Democratic)?
Provide a succinct answer. -1.66e+06. In the year 1998, what is the difference between the Aid flow (current US$) of Belize and Aid flow (current US$) of Macedonia?
Provide a short and direct response. -4.14e+06. In the year 1998, what is the difference between the Aid flow (current US$) in Equatorial Guinea and Aid flow (current US$) in Korea (Democratic)?
Your response must be concise. -1.72e+06. In the year 1998, what is the difference between the Aid flow (current US$) in Equatorial Guinea and Aid flow (current US$) in Macedonia?
Keep it short and to the point. -4.20e+06. In the year 1998, what is the difference between the Aid flow (current US$) of Korea (Democratic) and Aid flow (current US$) of Macedonia?
Make the answer very short. -2.48e+06. In the year 1999, what is the difference between the Aid flow (current US$) of Belize and Aid flow (current US$) of Equatorial Guinea?
Make the answer very short. 8.00e+04. In the year 1999, what is the difference between the Aid flow (current US$) in Belize and Aid flow (current US$) in Korea (Democratic)?
Provide a succinct answer. -2.76e+06. In the year 1999, what is the difference between the Aid flow (current US$) of Belize and Aid flow (current US$) of Macedonia?
Your answer should be very brief. -1.37e+07. In the year 1999, what is the difference between the Aid flow (current US$) of Equatorial Guinea and Aid flow (current US$) of Korea (Democratic)?
Offer a terse response. -2.84e+06. In the year 1999, what is the difference between the Aid flow (current US$) in Equatorial Guinea and Aid flow (current US$) in Macedonia?
Give a very brief answer. -1.38e+07. In the year 1999, what is the difference between the Aid flow (current US$) of Korea (Democratic) and Aid flow (current US$) of Macedonia?
Your response must be concise. -1.10e+07. In the year 2000, what is the difference between the Aid flow (current US$) of Belize and Aid flow (current US$) of Korea (Democratic)?
Your response must be concise. -1.32e+06. In the year 2000, what is the difference between the Aid flow (current US$) of Belize and Aid flow (current US$) of Macedonia?
Make the answer very short. -6.49e+06. In the year 2000, what is the difference between the Aid flow (current US$) in Equatorial Guinea and Aid flow (current US$) in Korea (Democratic)?
Your response must be concise. -1.47e+06. In the year 2000, what is the difference between the Aid flow (current US$) of Equatorial Guinea and Aid flow (current US$) of Macedonia?
Your answer should be very brief. -6.64e+06. In the year 2000, what is the difference between the Aid flow (current US$) in Korea (Democratic) and Aid flow (current US$) in Macedonia?
Offer a very short reply. -5.17e+06. In the year 2002, what is the difference between the Aid flow (current US$) of Belize and Aid flow (current US$) of Equatorial Guinea?
Your response must be concise. 2.00e+04. In the year 2002, what is the difference between the Aid flow (current US$) of Belize and Aid flow (current US$) of Korea (Democratic)?
Provide a succinct answer. -3.31e+07. In the year 2002, what is the difference between the Aid flow (current US$) of Belize and Aid flow (current US$) of Macedonia?
Your answer should be compact. -1.67e+07. In the year 2002, what is the difference between the Aid flow (current US$) of Equatorial Guinea and Aid flow (current US$) of Korea (Democratic)?
Keep it short and to the point. -3.31e+07. In the year 2002, what is the difference between the Aid flow (current US$) in Equatorial Guinea and Aid flow (current US$) in Macedonia?
Your response must be concise. -1.68e+07. In the year 2002, what is the difference between the Aid flow (current US$) of Korea (Democratic) and Aid flow (current US$) of Macedonia?
Provide a succinct answer. 1.63e+07. In the year 2008, what is the difference between the Aid flow (current US$) of Belize and Aid flow (current US$) of Equatorial Guinea?
Provide a succinct answer. 0. In the year 2008, what is the difference between the Aid flow (current US$) of Belize and Aid flow (current US$) of Korea (Democratic)?
Keep it short and to the point. -5.49e+06. In the year 2008, what is the difference between the Aid flow (current US$) in Belize and Aid flow (current US$) in Macedonia?
Provide a short and direct response. -2.48e+07. In the year 2008, what is the difference between the Aid flow (current US$) in Equatorial Guinea and Aid flow (current US$) in Korea (Democratic)?
Keep it short and to the point. -5.49e+06. In the year 2008, what is the difference between the Aid flow (current US$) of Equatorial Guinea and Aid flow (current US$) of Macedonia?
Give a very brief answer. -2.48e+07. In the year 2008, what is the difference between the Aid flow (current US$) of Korea (Democratic) and Aid flow (current US$) of Macedonia?
Offer a very short reply. -1.93e+07. In the year 2009, what is the difference between the Aid flow (current US$) of Belize and Aid flow (current US$) of Equatorial Guinea?
Your response must be concise. 0. In the year 2009, what is the difference between the Aid flow (current US$) in Belize and Aid flow (current US$) in Korea (Democratic)?
Offer a terse response. -2.68e+06. In the year 2009, what is the difference between the Aid flow (current US$) of Belize and Aid flow (current US$) of Macedonia?
Keep it short and to the point. -1.87e+07. In the year 2009, what is the difference between the Aid flow (current US$) of Equatorial Guinea and Aid flow (current US$) of Korea (Democratic)?
Your response must be concise. -2.68e+06. In the year 2009, what is the difference between the Aid flow (current US$) of Equatorial Guinea and Aid flow (current US$) of Macedonia?
Your answer should be compact. -1.87e+07. In the year 2009, what is the difference between the Aid flow (current US$) of Korea (Democratic) and Aid flow (current US$) of Macedonia?
Provide a short and direct response. -1.60e+07. What is the ratio of the Aid flow (current US$) in Equatorial Guinea in 1996 to that in 1997?
Provide a short and direct response. 0.43. What is the ratio of the Aid flow (current US$) in Korea (Democratic) in 1996 to that in 1997?
Keep it short and to the point. 0.18. What is the ratio of the Aid flow (current US$) of Macedonia in 1996 to that in 1997?
Your response must be concise. 2.63. What is the ratio of the Aid flow (current US$) of Belize in 1996 to that in 1998?
Provide a succinct answer. 0.77. What is the ratio of the Aid flow (current US$) in Equatorial Guinea in 1996 to that in 1998?
Your answer should be compact. 0.43. What is the ratio of the Aid flow (current US$) in Korea (Democratic) in 1996 to that in 1998?
Keep it short and to the point. 0.49. What is the ratio of the Aid flow (current US$) of Macedonia in 1996 to that in 1998?
Offer a very short reply. 1.91. What is the ratio of the Aid flow (current US$) of Belize in 1996 to that in 1999?
Give a very brief answer. 0.71. What is the ratio of the Aid flow (current US$) of Korea (Democratic) in 1996 to that in 1999?
Provide a short and direct response. 0.3. What is the ratio of the Aid flow (current US$) in Macedonia in 1996 to that in 1999?
Your response must be concise. 0.59. What is the ratio of the Aid flow (current US$) of Belize in 1996 to that in 2000?
Your answer should be very brief. 0.59. What is the ratio of the Aid flow (current US$) of Equatorial Guinea in 1996 to that in 2000?
Offer a terse response. 1.5. What is the ratio of the Aid flow (current US$) in Korea (Democratic) in 1996 to that in 2000?
Keep it short and to the point. 0.58. What is the ratio of the Aid flow (current US$) of Macedonia in 1996 to that in 2000?
Offer a terse response. 1.23. What is the ratio of the Aid flow (current US$) in Belize in 1996 to that in 2002?
Your response must be concise. 1.25. What is the ratio of the Aid flow (current US$) of Equatorial Guinea in 1996 to that in 2002?
Provide a succinct answer. 0.5. What is the ratio of the Aid flow (current US$) in Korea (Democratic) in 1996 to that in 2002?
Provide a short and direct response. 0.03. What is the ratio of the Aid flow (current US$) of Macedonia in 1996 to that in 2002?
Give a very brief answer. 0.49. What is the ratio of the Aid flow (current US$) in Equatorial Guinea in 1996 to that in 2008?
Your answer should be compact. 1.5. What is the ratio of the Aid flow (current US$) of Korea (Democratic) in 1996 to that in 2008?
Offer a very short reply. 0.16. What is the ratio of the Aid flow (current US$) in Macedonia in 1996 to that in 2008?
Your answer should be compact. 0.33. What is the ratio of the Aid flow (current US$) in Belize in 1996 to that in 2009?
Provide a short and direct response. 2.5. What is the ratio of the Aid flow (current US$) of Korea (Democratic) in 1996 to that in 2009?
Keep it short and to the point. 0.32. What is the ratio of the Aid flow (current US$) in Macedonia in 1996 to that in 2009?
Offer a very short reply. 0.44. What is the ratio of the Aid flow (current US$) of Belize in 1997 to that in 1998?
Make the answer very short. 0.69. What is the ratio of the Aid flow (current US$) of Equatorial Guinea in 1997 to that in 1998?
Provide a short and direct response. 1. What is the ratio of the Aid flow (current US$) in Korea (Democratic) in 1997 to that in 1998?
Keep it short and to the point. 2.68. What is the ratio of the Aid flow (current US$) of Macedonia in 1997 to that in 1998?
Your response must be concise. 0.73. What is the ratio of the Aid flow (current US$) of Belize in 1997 to that in 1999?
Provide a succinct answer. 0.64. What is the ratio of the Aid flow (current US$) in Equatorial Guinea in 1997 to that in 1999?
Your response must be concise. 1.17. What is the ratio of the Aid flow (current US$) of Korea (Democratic) in 1997 to that in 1999?
Provide a succinct answer. 1.65. What is the ratio of the Aid flow (current US$) of Macedonia in 1997 to that in 1999?
Keep it short and to the point. 0.22. What is the ratio of the Aid flow (current US$) in Belize in 1997 to that in 2000?
Your answer should be compact. 0.53. What is the ratio of the Aid flow (current US$) in Equatorial Guinea in 1997 to that in 2000?
Keep it short and to the point. 3.5. What is the ratio of the Aid flow (current US$) in Korea (Democratic) in 1997 to that in 2000?
Provide a short and direct response. 3.21. What is the ratio of the Aid flow (current US$) in Macedonia in 1997 to that in 2000?
Provide a succinct answer. 0.47. What is the ratio of the Aid flow (current US$) in Belize in 1997 to that in 2002?
Provide a succinct answer. 1.12. What is the ratio of the Aid flow (current US$) of Equatorial Guinea in 1997 to that in 2002?
Give a very brief answer. 1.17. What is the ratio of the Aid flow (current US$) of Korea (Democratic) in 1997 to that in 2002?
Your answer should be compact. 0.14. What is the ratio of the Aid flow (current US$) in Macedonia in 1997 to that in 2002?
Your answer should be very brief. 0.18. What is the ratio of the Aid flow (current US$) in Belize in 1997 to that in 2008?
Your answer should be very brief. 4.5. What is the ratio of the Aid flow (current US$) of Equatorial Guinea in 1997 to that in 2008?
Your answer should be very brief. 3.5. What is the ratio of the Aid flow (current US$) in Korea (Democratic) in 1997 to that in 2008?
Offer a terse response. 0.87. What is the ratio of the Aid flow (current US$) of Macedonia in 1997 to that in 2008?
Your answer should be very brief. 0.13. What is the ratio of the Aid flow (current US$) in Belize in 1997 to that in 2009?
Offer a terse response. 2.25. What is the ratio of the Aid flow (current US$) in Korea (Democratic) in 1997 to that in 2009?
Your response must be concise. 1.76. What is the ratio of the Aid flow (current US$) of Macedonia in 1997 to that in 2009?
Offer a terse response. 0.17. What is the ratio of the Aid flow (current US$) of Belize in 1998 to that in 1999?
Offer a terse response. 0.93. What is the ratio of the Aid flow (current US$) in Korea (Democratic) in 1998 to that in 1999?
Give a very brief answer. 0.62. What is the ratio of the Aid flow (current US$) of Macedonia in 1998 to that in 1999?
Ensure brevity in your answer.  0.31. What is the ratio of the Aid flow (current US$) in Belize in 1998 to that in 2000?
Provide a short and direct response. 0.76. What is the ratio of the Aid flow (current US$) in Equatorial Guinea in 1998 to that in 2000?
Keep it short and to the point. 3.5. What is the ratio of the Aid flow (current US$) of Korea (Democratic) in 1998 to that in 2000?
Provide a short and direct response. 1.2. What is the ratio of the Aid flow (current US$) of Macedonia in 1998 to that in 2000?
Keep it short and to the point. 0.64. What is the ratio of the Aid flow (current US$) in Belize in 1998 to that in 2002?
Ensure brevity in your answer.  1.62. What is the ratio of the Aid flow (current US$) of Korea (Democratic) in 1998 to that in 2002?
Your answer should be compact. 0.05. What is the ratio of the Aid flow (current US$) of Macedonia in 1998 to that in 2002?
Keep it short and to the point. 0.25. What is the ratio of the Aid flow (current US$) in Belize in 1998 to that in 2008?
Offer a terse response. 6.5. What is the ratio of the Aid flow (current US$) in Equatorial Guinea in 1998 to that in 2008?
Your answer should be very brief. 3.5. What is the ratio of the Aid flow (current US$) of Korea (Democratic) in 1998 to that in 2008?
Provide a short and direct response. 0.32. What is the ratio of the Aid flow (current US$) of Macedonia in 1998 to that in 2008?
Provide a succinct answer. 0.17. What is the ratio of the Aid flow (current US$) of Equatorial Guinea in 1998 to that in 2009?
Offer a terse response. 1.75. What is the ratio of the Aid flow (current US$) of Korea (Democratic) in 1998 to that in 2009?
Provide a succinct answer. 0.66. What is the ratio of the Aid flow (current US$) in Macedonia in 1998 to that in 2009?
Provide a succinct answer. 0.23. What is the ratio of the Aid flow (current US$) of Belize in 1999 to that in 2000?
Provide a succinct answer. 0.82. What is the ratio of the Aid flow (current US$) in Korea (Democratic) in 1999 to that in 2000?
Your response must be concise. 1.95. What is the ratio of the Aid flow (current US$) in Macedonia in 1999 to that in 2000?
Your answer should be compact. 2.08. What is the ratio of the Aid flow (current US$) in Belize in 1999 to that in 2002?
Your answer should be very brief. 1.75. What is the ratio of the Aid flow (current US$) of Equatorial Guinea in 1999 to that in 2002?
Make the answer very short. 1. What is the ratio of the Aid flow (current US$) in Korea (Democratic) in 1999 to that in 2002?
Your response must be concise. 0.09. What is the ratio of the Aid flow (current US$) of Macedonia in 1999 to that in 2002?
Make the answer very short. 0.82. What is the ratio of the Aid flow (current US$) in Korea (Democratic) in 1999 to that in 2008?
Offer a very short reply. 0.53. What is the ratio of the Aid flow (current US$) in Macedonia in 1999 to that in 2008?
Offer a terse response. 0.56. What is the ratio of the Aid flow (current US$) in Korea (Democratic) in 1999 to that in 2009?
Make the answer very short. 1.07. What is the ratio of the Aid flow (current US$) of Macedonia in 1999 to that in 2009?
Your answer should be compact. 0.74. What is the ratio of the Aid flow (current US$) of Belize in 2000 to that in 2002?
Your answer should be very brief. 2.12. What is the ratio of the Aid flow (current US$) of Korea (Democratic) in 2000 to that in 2002?
Keep it short and to the point. 0.04. What is the ratio of the Aid flow (current US$) in Macedonia in 2000 to that in 2002?
Ensure brevity in your answer.  0.4. What is the ratio of the Aid flow (current US$) of Belize in 2000 to that in 2008?
Your answer should be compact. 8.5. What is the ratio of the Aid flow (current US$) of Korea (Democratic) in 2000 to that in 2008?
Your response must be concise. 0.27. What is the ratio of the Aid flow (current US$) in Macedonia in 2000 to that in 2008?
Your response must be concise. 0.27. What is the ratio of the Aid flow (current US$) in Belize in 2000 to that in 2009?
Your answer should be compact. 4.25. What is the ratio of the Aid flow (current US$) of Equatorial Guinea in 2000 to that in 2009?
Offer a very short reply. 0.5. What is the ratio of the Aid flow (current US$) in Korea (Democratic) in 2000 to that in 2009?
Keep it short and to the point. 0.55. What is the ratio of the Aid flow (current US$) of Macedonia in 2000 to that in 2009?
Offer a terse response. 0.35. What is the ratio of the Aid flow (current US$) of Belize in 2002 to that in 2008?
Give a very brief answer. 4. What is the ratio of the Aid flow (current US$) of Equatorial Guinea in 2002 to that in 2008?
Your answer should be compact. 3. What is the ratio of the Aid flow (current US$) of Korea (Democratic) in 2002 to that in 2008?
Make the answer very short. 6.02. What is the ratio of the Aid flow (current US$) in Macedonia in 2002 to that in 2008?
Your response must be concise. 0.68. What is the ratio of the Aid flow (current US$) in Belize in 2002 to that in 2009?
Give a very brief answer. 2. What is the ratio of the Aid flow (current US$) of Equatorial Guinea in 2002 to that in 2009?
Provide a short and direct response. 1.5. What is the ratio of the Aid flow (current US$) of Korea (Democratic) in 2002 to that in 2009?
Ensure brevity in your answer.  12.19. What is the ratio of the Aid flow (current US$) in Macedonia in 2002 to that in 2009?
Your response must be concise. 0.9. What is the ratio of the Aid flow (current US$) of Belize in 2008 to that in 2009?
Your answer should be very brief. 0.5. What is the ratio of the Aid flow (current US$) of Korea (Democratic) in 2008 to that in 2009?
Ensure brevity in your answer.  2.03. What is the ratio of the Aid flow (current US$) in Macedonia in 2008 to that in 2009?
Your answer should be compact. 1.32. What is the difference between the highest and the second highest Aid flow (current US$) of Korea (Democratic)?
Your answer should be compact. 2.76e+07. What is the difference between the highest and the second highest Aid flow (current US$) in Macedonia?
Offer a terse response. 6.00e+06. What is the difference between the highest and the lowest Aid flow (current US$) of Belize?
Keep it short and to the point. 1.50e+05. What is the difference between the highest and the lowest Aid flow (current US$) of Korea (Democratic)?
Offer a very short reply. 3.23e+07. What is the difference between the highest and the lowest Aid flow (current US$) in Macedonia?
Your response must be concise. 2.17e+07. 